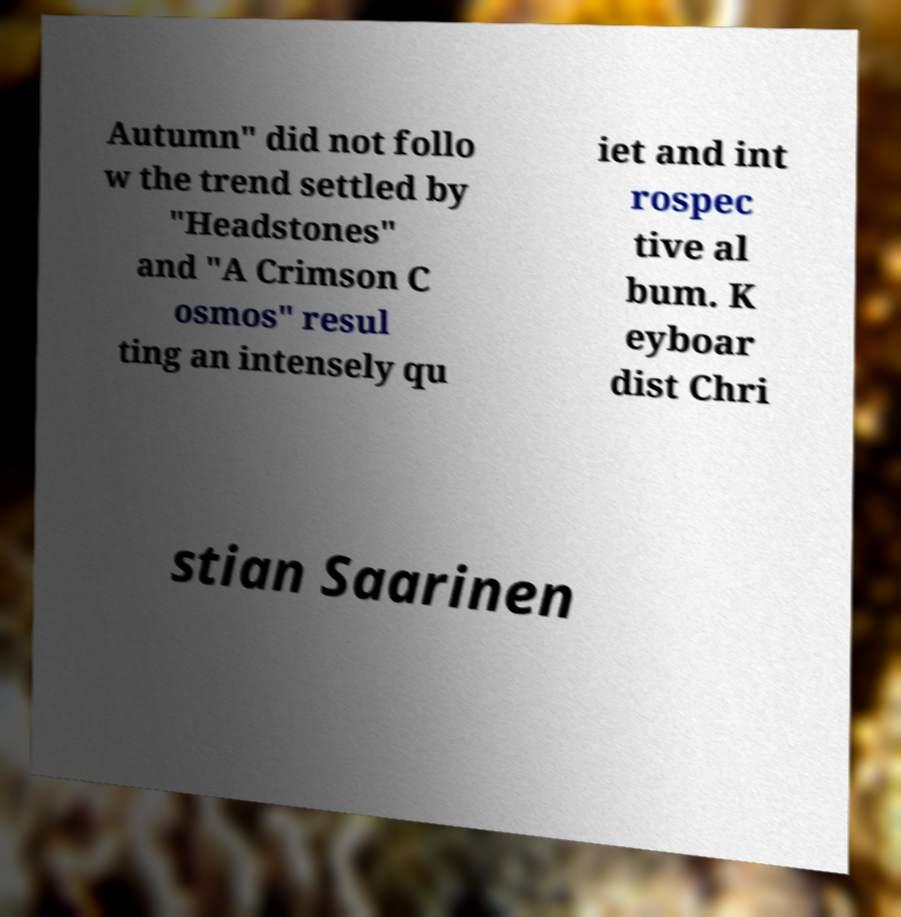What messages or text are displayed in this image? I need them in a readable, typed format. Autumn" did not follo w the trend settled by "Headstones" and "A Crimson C osmos" resul ting an intensely qu iet and int rospec tive al bum. K eyboar dist Chri stian Saarinen 